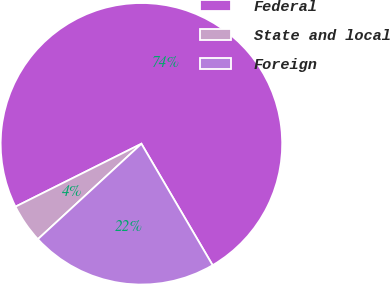Convert chart. <chart><loc_0><loc_0><loc_500><loc_500><pie_chart><fcel>Federal<fcel>State and local<fcel>Foreign<nl><fcel>73.93%<fcel>4.48%<fcel>21.59%<nl></chart> 